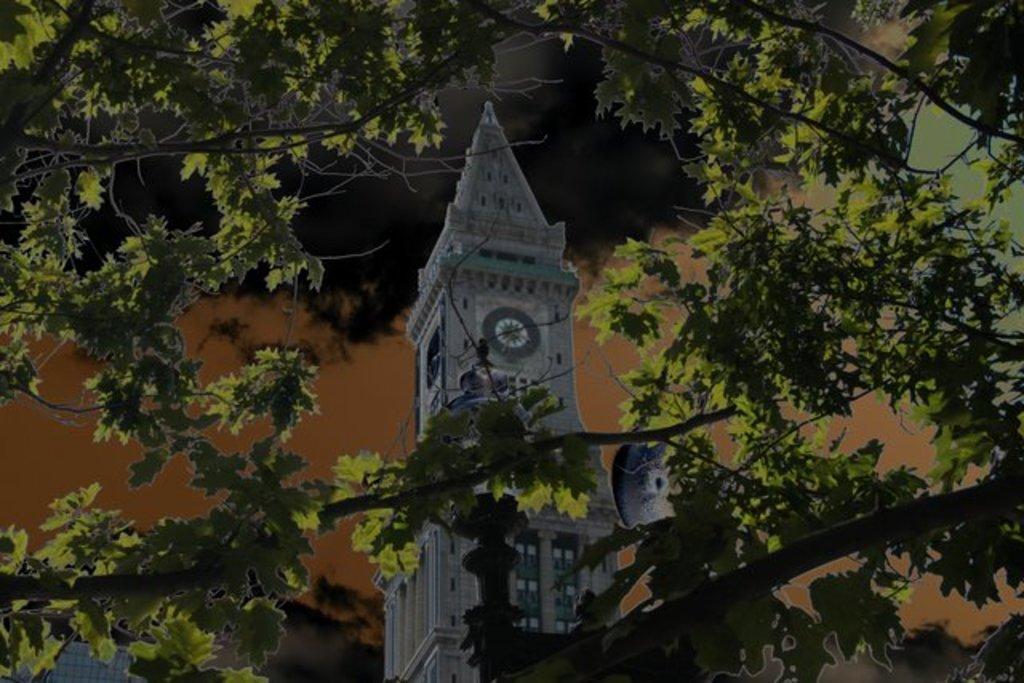Please provide a concise description of this image. In the picture we can see a clock tower with a clock to it, near it we can see a tree. 